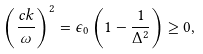<formula> <loc_0><loc_0><loc_500><loc_500>\left ( \frac { c k } { \omega } \right ) ^ { 2 } = \epsilon _ { 0 } \left ( 1 - \frac { 1 } { \Delta ^ { 2 } } \right ) \geq 0 ,</formula> 